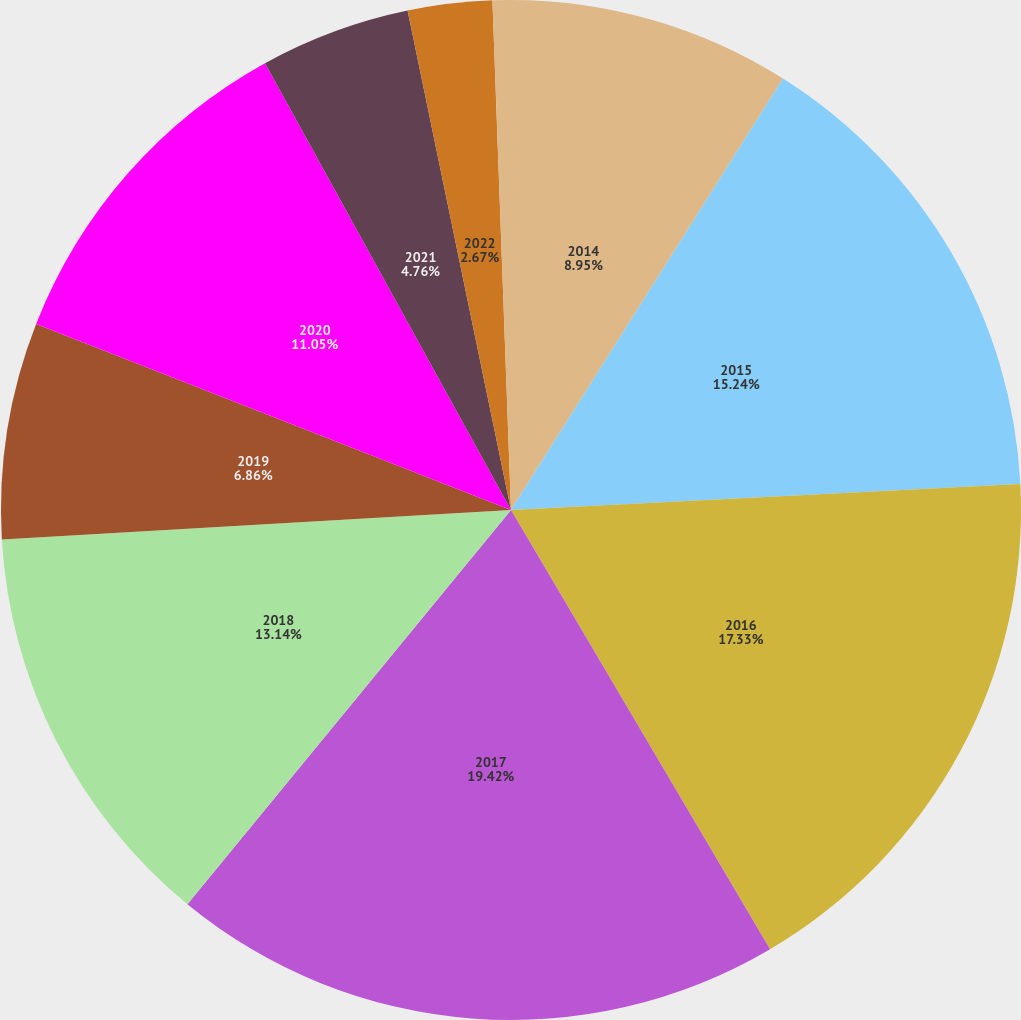Convert chart to OTSL. <chart><loc_0><loc_0><loc_500><loc_500><pie_chart><fcel>2014<fcel>2015<fcel>2016<fcel>2017<fcel>2018<fcel>2019<fcel>2020<fcel>2021<fcel>2022<fcel>2023<nl><fcel>8.95%<fcel>15.24%<fcel>17.33%<fcel>19.42%<fcel>13.14%<fcel>6.86%<fcel>11.05%<fcel>4.76%<fcel>2.67%<fcel>0.58%<nl></chart> 